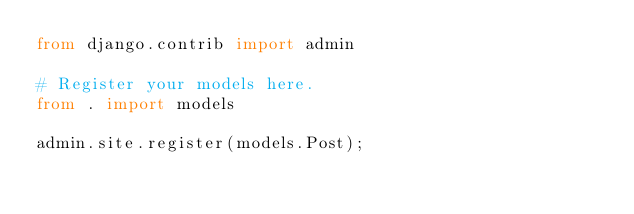Convert code to text. <code><loc_0><loc_0><loc_500><loc_500><_Python_>from django.contrib import admin

# Register your models here.
from . import models

admin.site.register(models.Post);</code> 